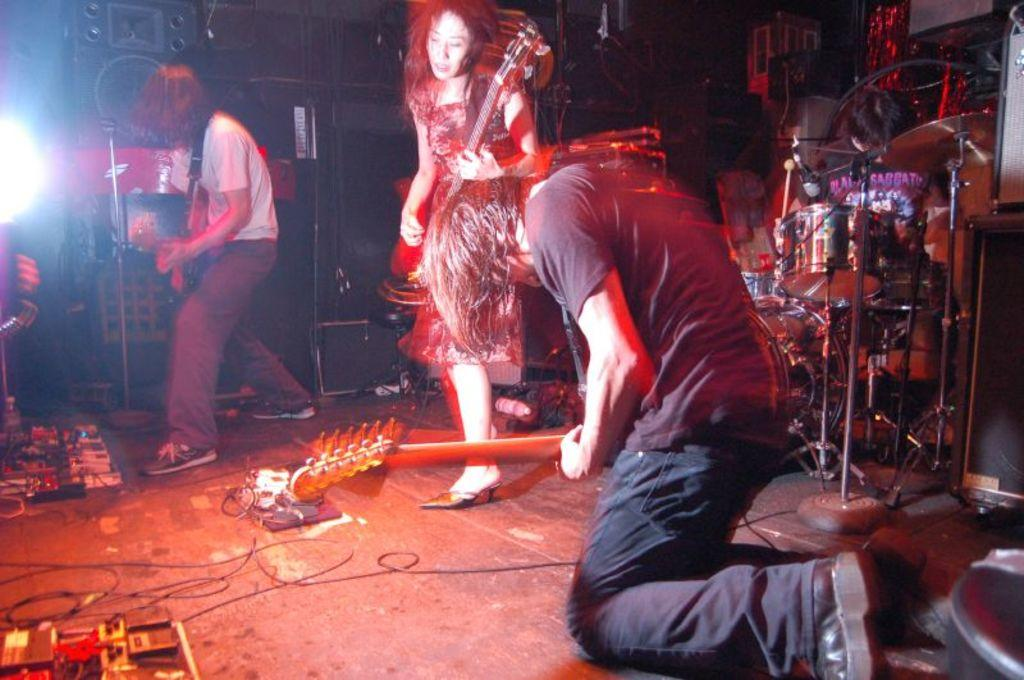What is happening on stage in the image? There are people on stage in the image, and they are playing musical instruments. What can be seen in the image besides the people on stage? There are wires visible in the image. What is in the background of the image? There are objects in the background of the image. Can you tell me what time it is on stage in the image? There is no watch or any indication of time in the image. 